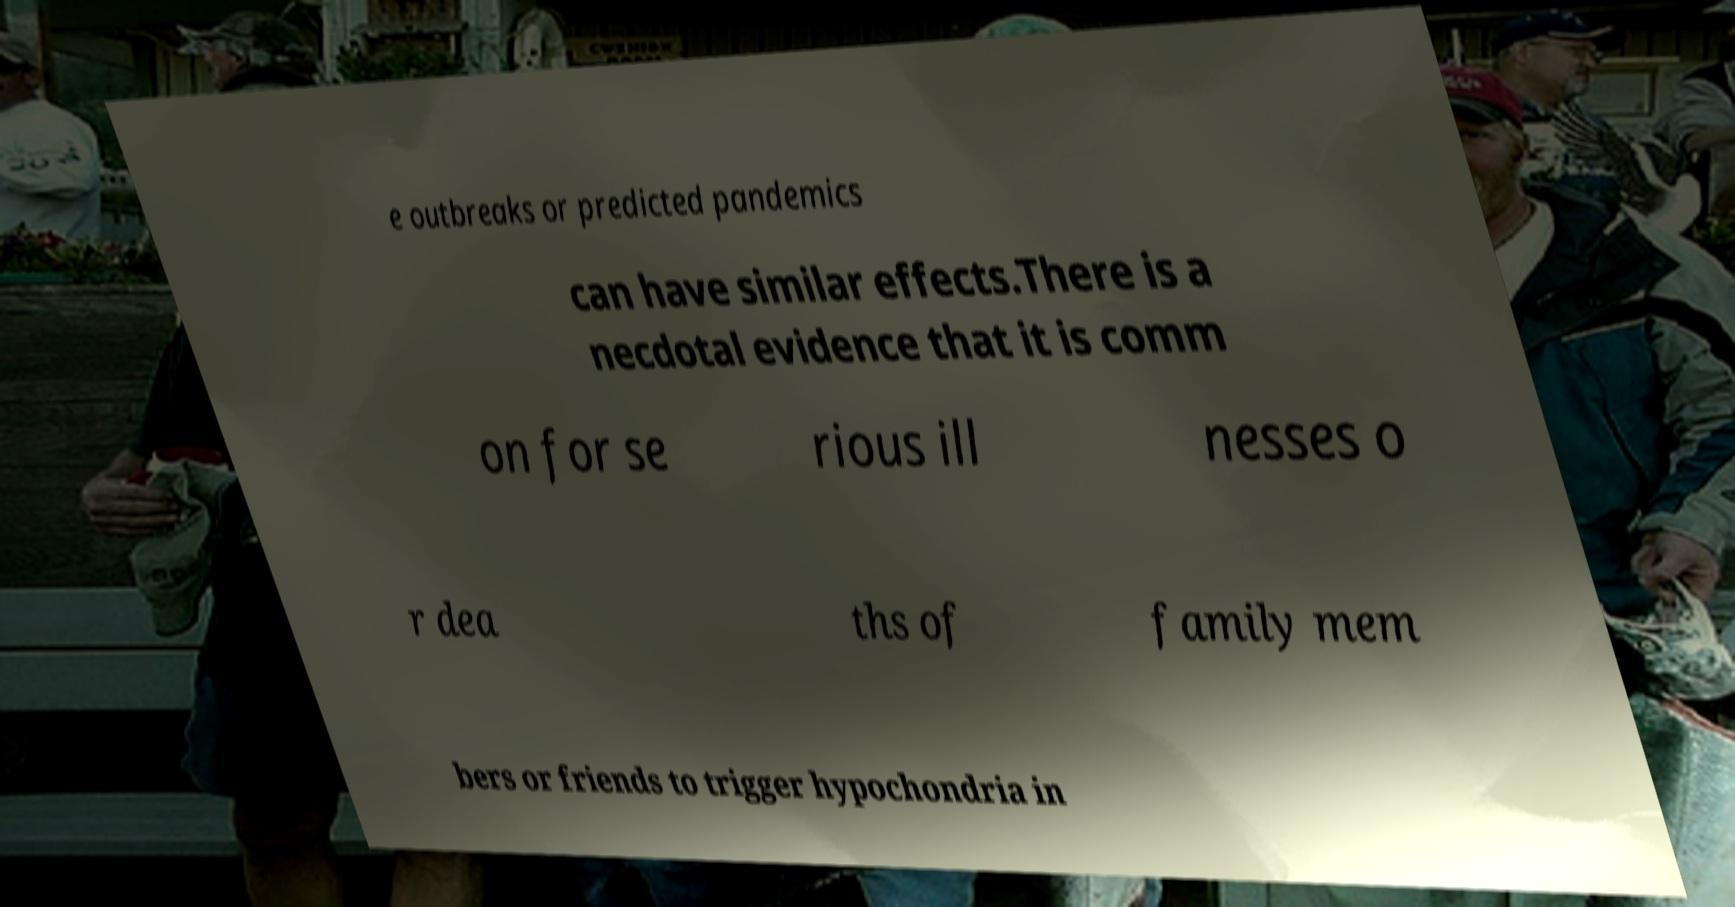I need the written content from this picture converted into text. Can you do that? e outbreaks or predicted pandemics can have similar effects.There is a necdotal evidence that it is comm on for se rious ill nesses o r dea ths of family mem bers or friends to trigger hypochondria in 